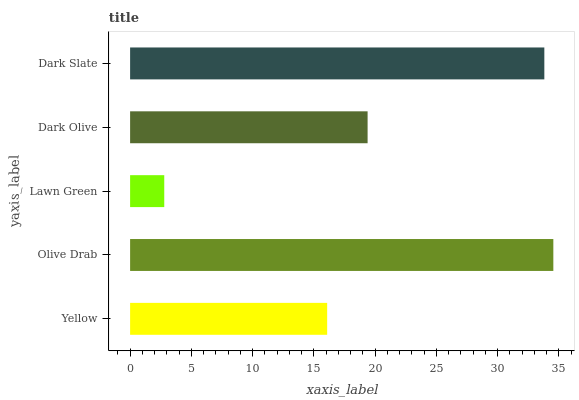Is Lawn Green the minimum?
Answer yes or no. Yes. Is Olive Drab the maximum?
Answer yes or no. Yes. Is Olive Drab the minimum?
Answer yes or no. No. Is Lawn Green the maximum?
Answer yes or no. No. Is Olive Drab greater than Lawn Green?
Answer yes or no. Yes. Is Lawn Green less than Olive Drab?
Answer yes or no. Yes. Is Lawn Green greater than Olive Drab?
Answer yes or no. No. Is Olive Drab less than Lawn Green?
Answer yes or no. No. Is Dark Olive the high median?
Answer yes or no. Yes. Is Dark Olive the low median?
Answer yes or no. Yes. Is Dark Slate the high median?
Answer yes or no. No. Is Yellow the low median?
Answer yes or no. No. 